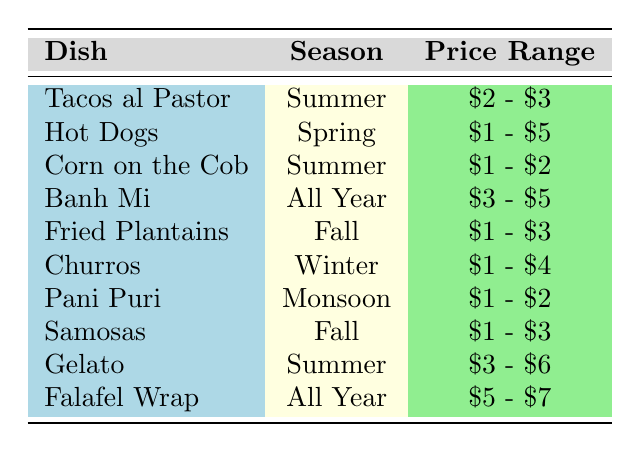What is the price range for Tacos al Pastor? According to the table, the price range is directly listed next to the dish 'Tacos al Pastor'. The price range given is '$2 - $3'.
Answer: $2 - $3 Which street food dish is available in all seasons? The table lists 'Banh Mi' and 'Falafel Wrap' as the only dishes available in 'All Year.' Therefore, both are correct answers.
Answer: Banh Mi, Falafel Wrap How many street food dishes are priced under $3? By examining the price range of each dish, 'Hot Dogs', 'Corn on the Cob', 'Fried Plantains', 'Samosas', 'Pani Puri', and 'Churros' are all priced under $3 (either included in or only included in the range that starts from $1). Counting these, we find there are 6 dishes priced under $3.
Answer: 6 Is Gelato available during the Winter season? Looking at the table, Gelato is listed under the 'Summer' season, which confirms that it is not available in Winter. Therefore, the answer is 'No.'
Answer: No What is the average price range of the dishes available in the Fall season? The dishes available in Fall are 'Fried Plantains' ($1 - $3) and 'Samosas' ($1 - $3). To find the average price range, we take the lowest prices ($1 + $1)/2 = $1 and the highest prices ($3 + $3)/2 = $3. Therefore, the average price range for Fall dishes is '$1 - $3'.
Answer: $1 - $3 Are there more dishes available in Summer than in any other season? Checking the table, there are 3 dishes in Summer (Tacos al Pastor, Corn on the Cob, Gelato). The other seasons have fewer dishes (Spring - 1, Fall - 2, Winter - 1, Monsoon - 1). Thus, the answer is 'Yes' since 3 is greater than any of the other counts.
Answer: Yes What is the price difference between the most expensive and least expensive dish? The most expensive dish is 'Falafel Wrap' at '$5 - $7' while the least expensive dishes like 'Pani Puri' are at '$1 - $2'. The range of values allows us to extract $7 (since it is the upper limit of 'Falafel Wrap') and $1 (the lower limit of 'Pani Puri'). The difference is $7 - $1 = $6.
Answer: $6 